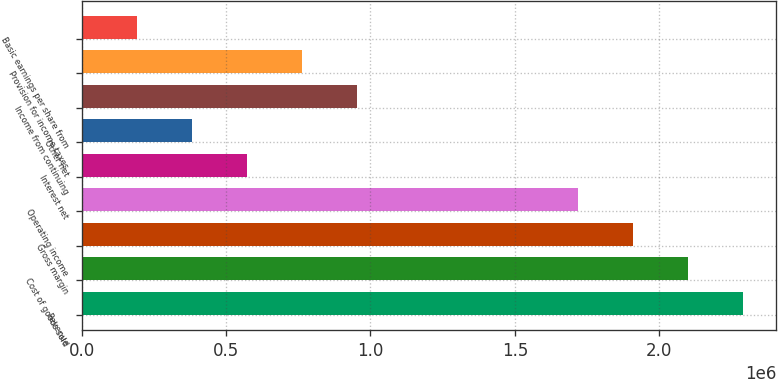Convert chart to OTSL. <chart><loc_0><loc_0><loc_500><loc_500><bar_chart><fcel>Revenue<fcel>Cost of goods sold<fcel>Gross margin<fcel>Operating income<fcel>Interest net<fcel>Other net<fcel>Income from continuing<fcel>Provision for income taxes<fcel>Basic earnings per share from<nl><fcel>2.29024e+06<fcel>2.09939e+06<fcel>1.90853e+06<fcel>1.71768e+06<fcel>572560<fcel>381707<fcel>954266<fcel>763413<fcel>190854<nl></chart> 